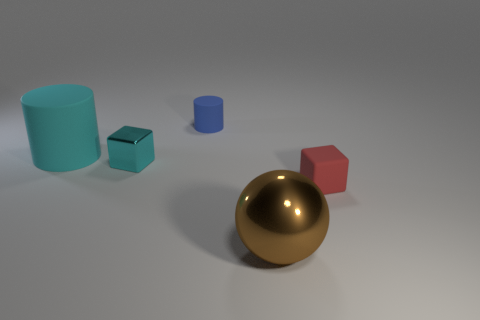Add 1 tiny cyan metal cubes. How many objects exist? 6 Subtract all cylinders. How many objects are left? 3 Add 3 large cyan cylinders. How many large cyan cylinders exist? 4 Subtract 0 green balls. How many objects are left? 5 Subtract all big blue matte blocks. Subtract all shiny spheres. How many objects are left? 4 Add 5 tiny blue rubber cylinders. How many tiny blue rubber cylinders are left? 6 